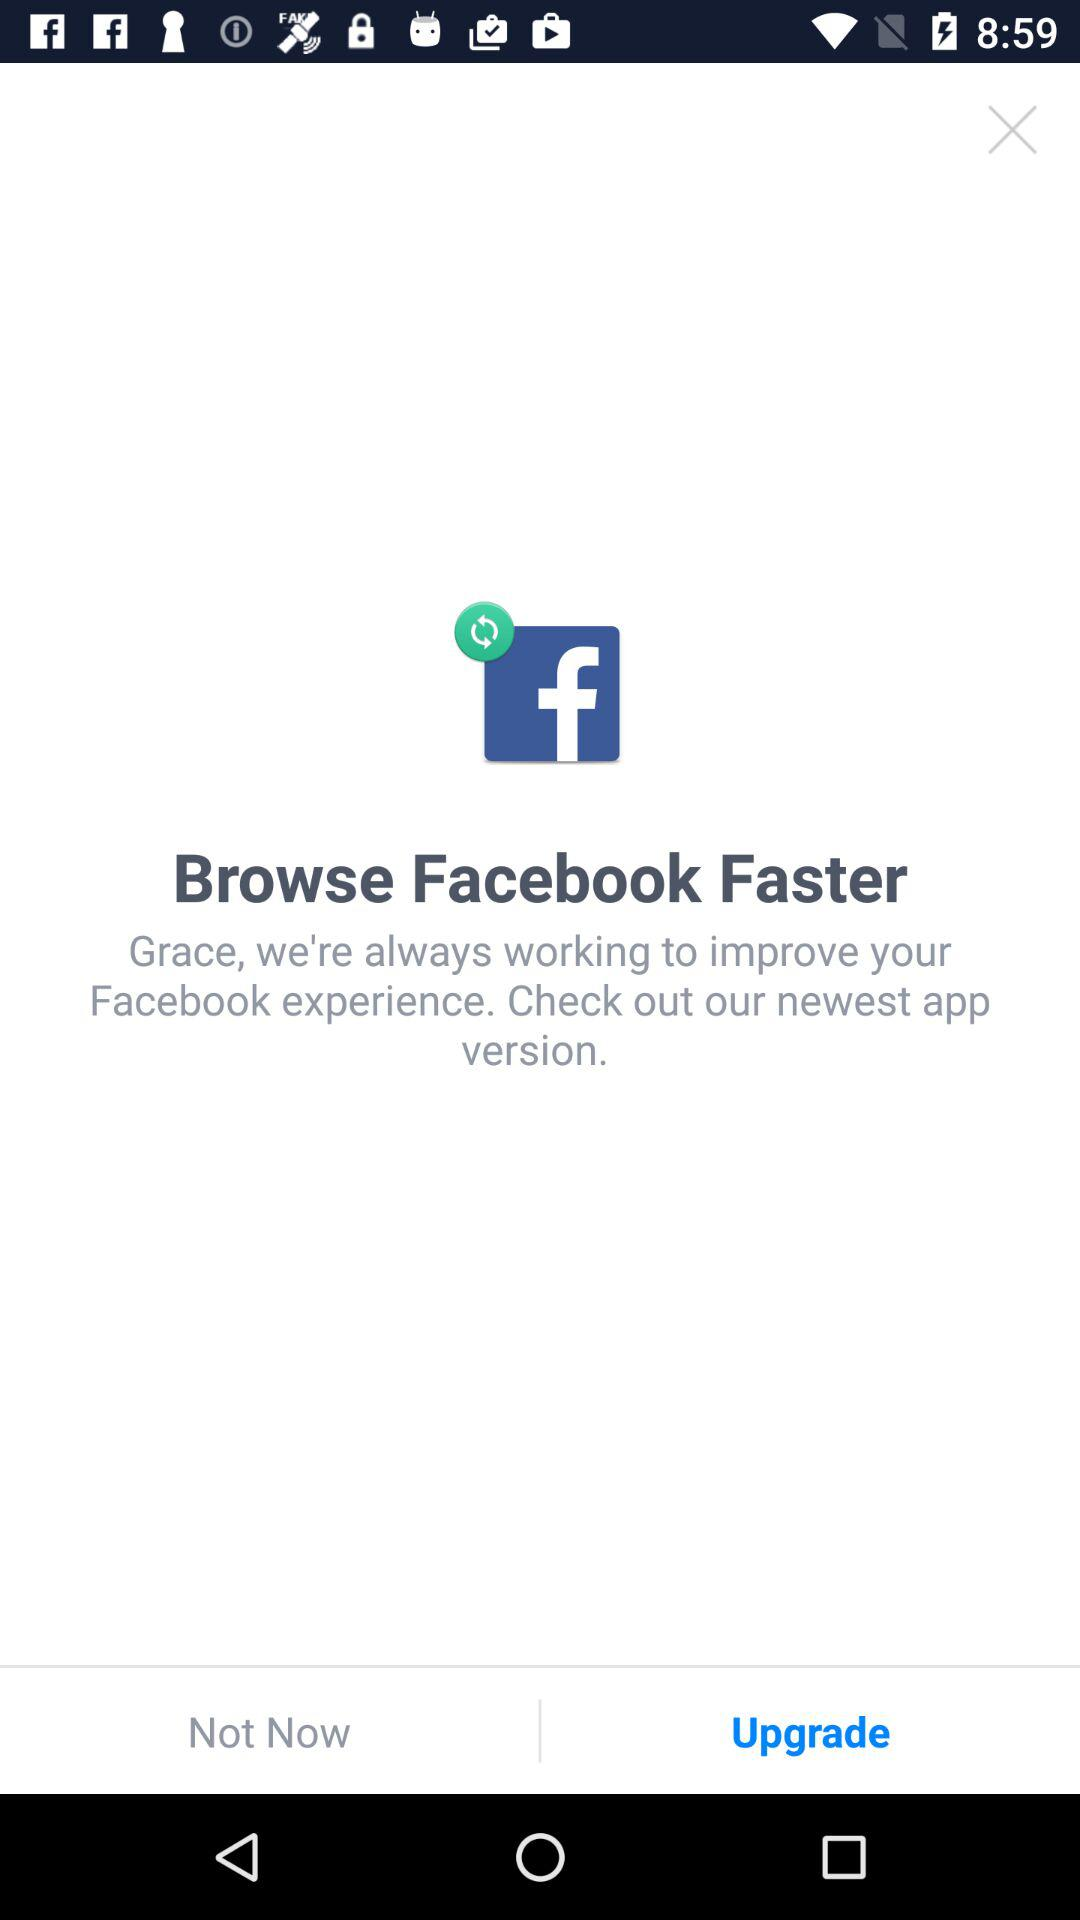Which application is asking to upgrade Facebook?
When the provided information is insufficient, respond with <no answer>. <no answer> 